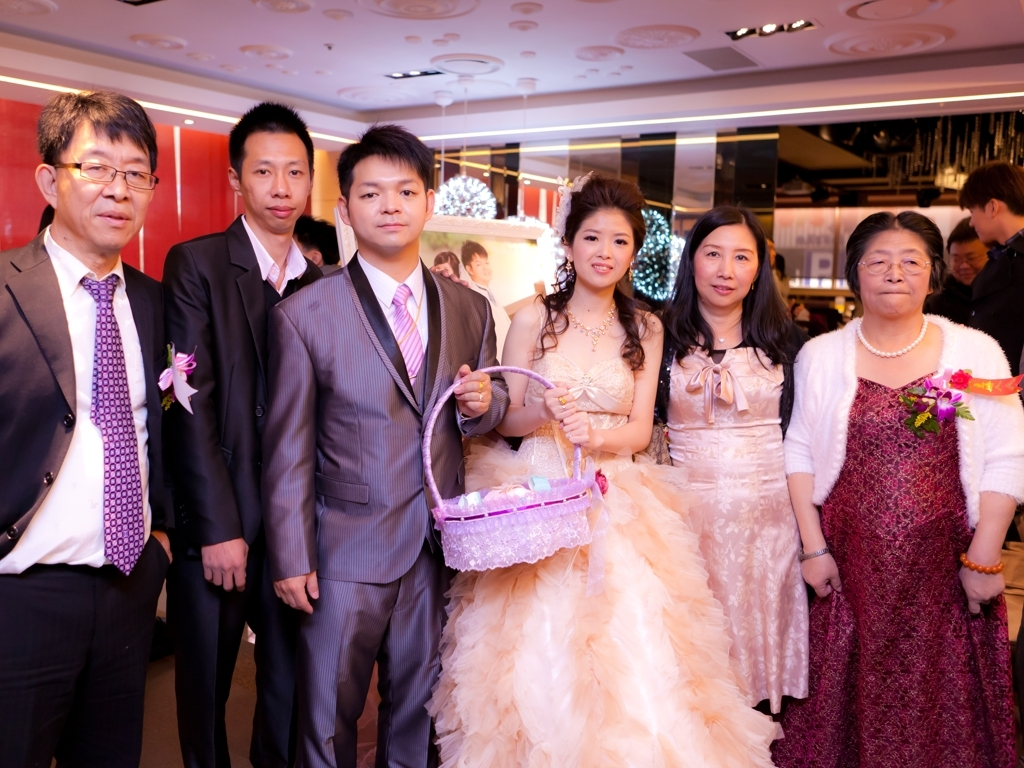What can you infer about the cultural significance of the attire worn by the individuals in the image? The attire worn by the individuals suggests cultural influences that value formal presentation and elegance during important celebrations. The dresses worn by the women are elaborate, with one resembling a bridal gown, often found in East Asian wedding traditions. The men are in suits, which demonstrates a fusion of Western-style formal wear with cultural preferences for certain colors and patterns, like the ties and shirts they've chosen. Overall, the attire reflects a respect for traditional elegance with a potential blend of modern or international influences. 